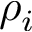<formula> <loc_0><loc_0><loc_500><loc_500>\rho _ { i }</formula> 